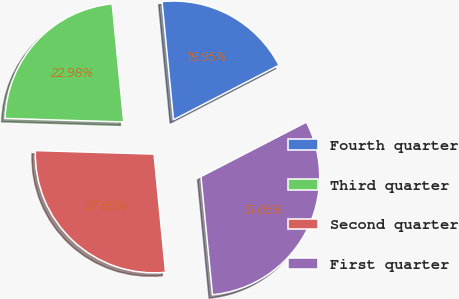Convert chart. <chart><loc_0><loc_0><loc_500><loc_500><pie_chart><fcel>Fourth quarter<fcel>Third quarter<fcel>Second quarter<fcel>First quarter<nl><fcel>18.95%<fcel>22.98%<fcel>27.02%<fcel>31.05%<nl></chart> 